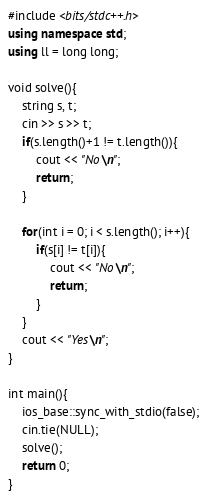<code> <loc_0><loc_0><loc_500><loc_500><_C++_>#include <bits/stdc++.h>
using namespace std;
using ll = long long;

void solve(){
    string s, t;
    cin >> s >> t;
    if(s.length()+1 != t.length()){
        cout << "No\n";
        return;
    }

    for(int i = 0; i < s.length(); i++){
        if(s[i] != t[i]){
            cout << "No\n";
            return;
        }
    }
    cout << "Yes\n";
}

int main(){
    ios_base::sync_with_stdio(false);
    cin.tie(NULL);
    solve();
    return 0;
}
</code> 